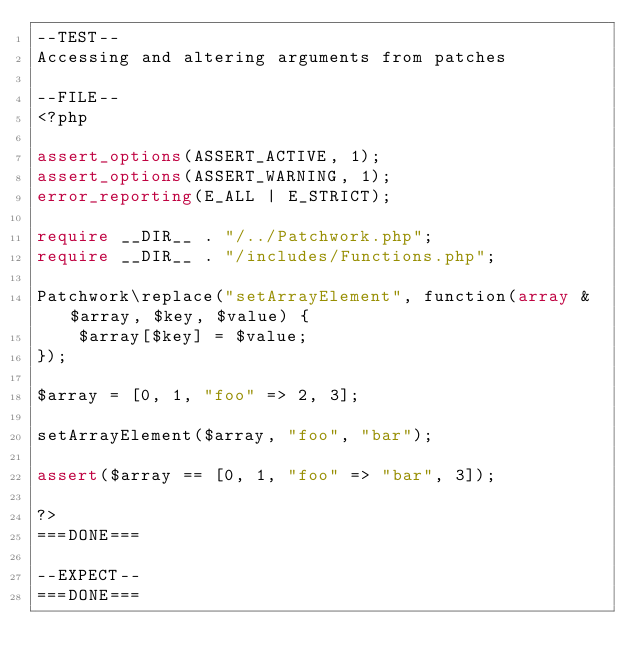Convert code to text. <code><loc_0><loc_0><loc_500><loc_500><_PHP_>--TEST--
Accessing and altering arguments from patches

--FILE--
<?php

assert_options(ASSERT_ACTIVE, 1);
assert_options(ASSERT_WARNING, 1);
error_reporting(E_ALL | E_STRICT);

require __DIR__ . "/../Patchwork.php";
require __DIR__ . "/includes/Functions.php";

Patchwork\replace("setArrayElement", function(array &$array, $key, $value) {
    $array[$key] = $value;
});

$array = [0, 1, "foo" => 2, 3];

setArrayElement($array, "foo", "bar");

assert($array == [0, 1, "foo" => "bar", 3]);

?>
===DONE===

--EXPECT--
===DONE===
</code> 